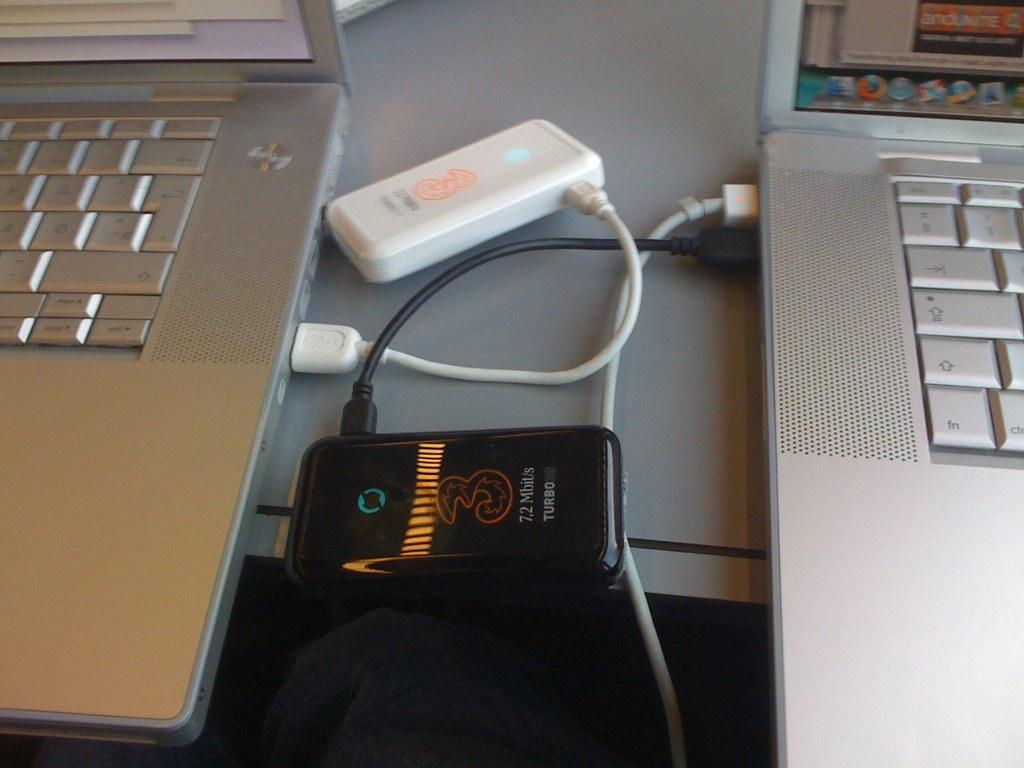<image>
Relay a brief, clear account of the picture shown. a black item that says turbo on it 